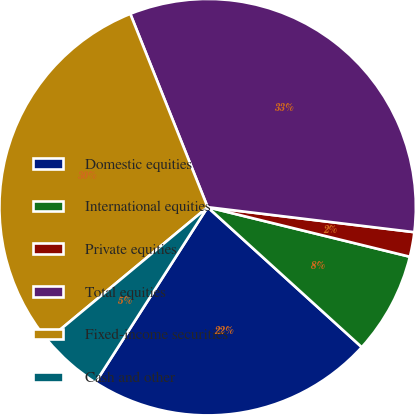Convert chart. <chart><loc_0><loc_0><loc_500><loc_500><pie_chart><fcel>Domestic equities<fcel>International equities<fcel>Private equities<fcel>Total equities<fcel>Fixed-income securities<fcel>Cash and other<nl><fcel>22.32%<fcel>7.91%<fcel>1.91%<fcel>32.97%<fcel>29.97%<fcel>4.91%<nl></chart> 